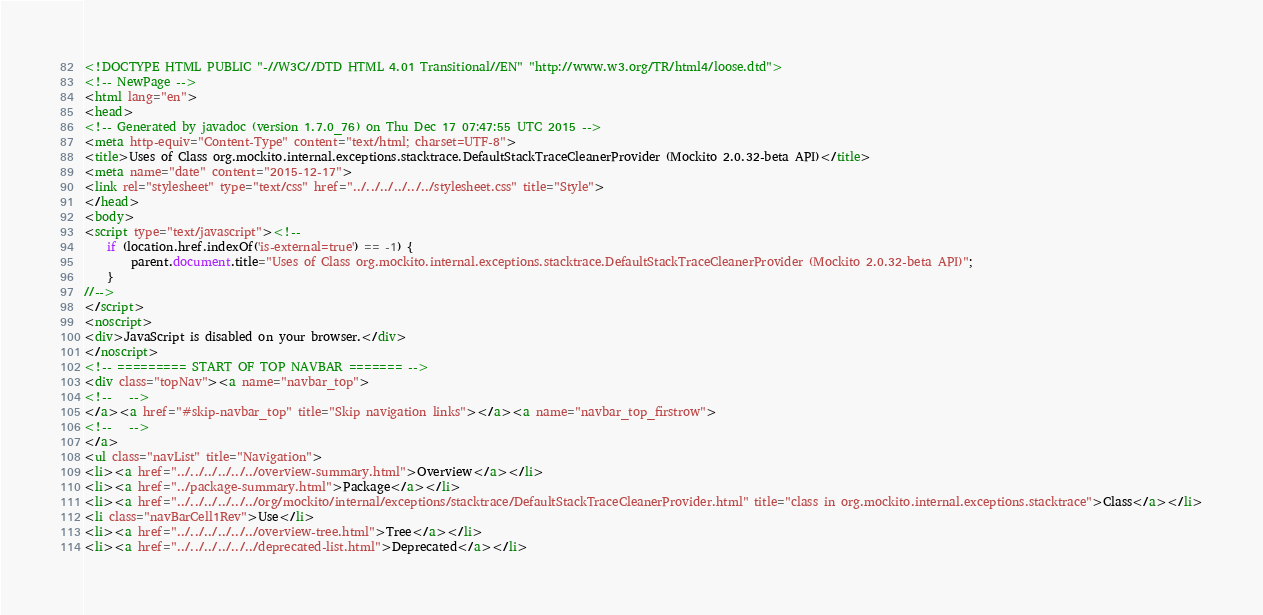Convert code to text. <code><loc_0><loc_0><loc_500><loc_500><_HTML_><!DOCTYPE HTML PUBLIC "-//W3C//DTD HTML 4.01 Transitional//EN" "http://www.w3.org/TR/html4/loose.dtd">
<!-- NewPage -->
<html lang="en">
<head>
<!-- Generated by javadoc (version 1.7.0_76) on Thu Dec 17 07:47:55 UTC 2015 -->
<meta http-equiv="Content-Type" content="text/html; charset=UTF-8">
<title>Uses of Class org.mockito.internal.exceptions.stacktrace.DefaultStackTraceCleanerProvider (Mockito 2.0.32-beta API)</title>
<meta name="date" content="2015-12-17">
<link rel="stylesheet" type="text/css" href="../../../../../../stylesheet.css" title="Style">
</head>
<body>
<script type="text/javascript"><!--
    if (location.href.indexOf('is-external=true') == -1) {
        parent.document.title="Uses of Class org.mockito.internal.exceptions.stacktrace.DefaultStackTraceCleanerProvider (Mockito 2.0.32-beta API)";
    }
//-->
</script>
<noscript>
<div>JavaScript is disabled on your browser.</div>
</noscript>
<!-- ========= START OF TOP NAVBAR ======= -->
<div class="topNav"><a name="navbar_top">
<!--   -->
</a><a href="#skip-navbar_top" title="Skip navigation links"></a><a name="navbar_top_firstrow">
<!--   -->
</a>
<ul class="navList" title="Navigation">
<li><a href="../../../../../../overview-summary.html">Overview</a></li>
<li><a href="../package-summary.html">Package</a></li>
<li><a href="../../../../../../org/mockito/internal/exceptions/stacktrace/DefaultStackTraceCleanerProvider.html" title="class in org.mockito.internal.exceptions.stacktrace">Class</a></li>
<li class="navBarCell1Rev">Use</li>
<li><a href="../../../../../../overview-tree.html">Tree</a></li>
<li><a href="../../../../../../deprecated-list.html">Deprecated</a></li></code> 